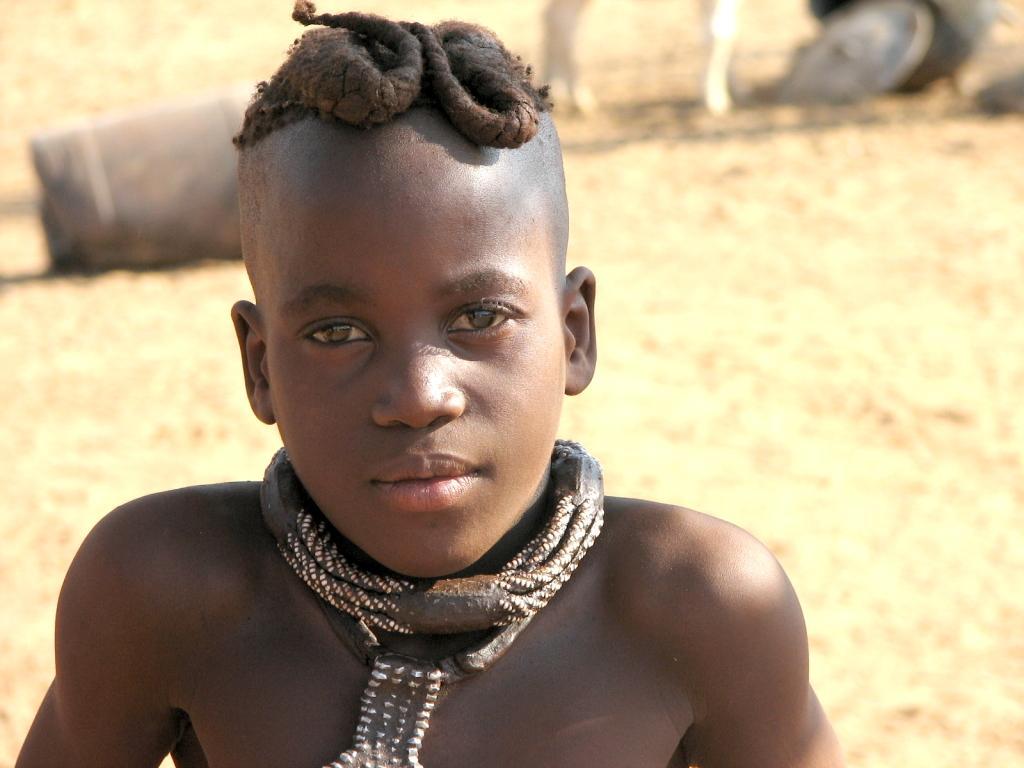In one or two sentences, can you explain what this image depicts? In this picture there is a boy with an ornament around his neck. At the back there are objects. At the bottom there is a sand. 